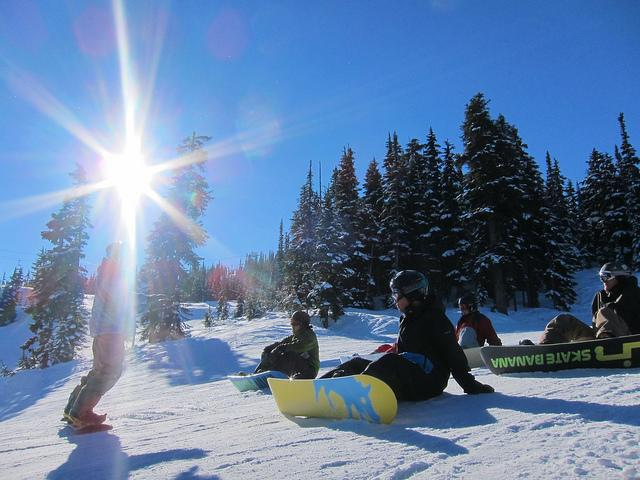Who is the man standing in front of the group? instructor 